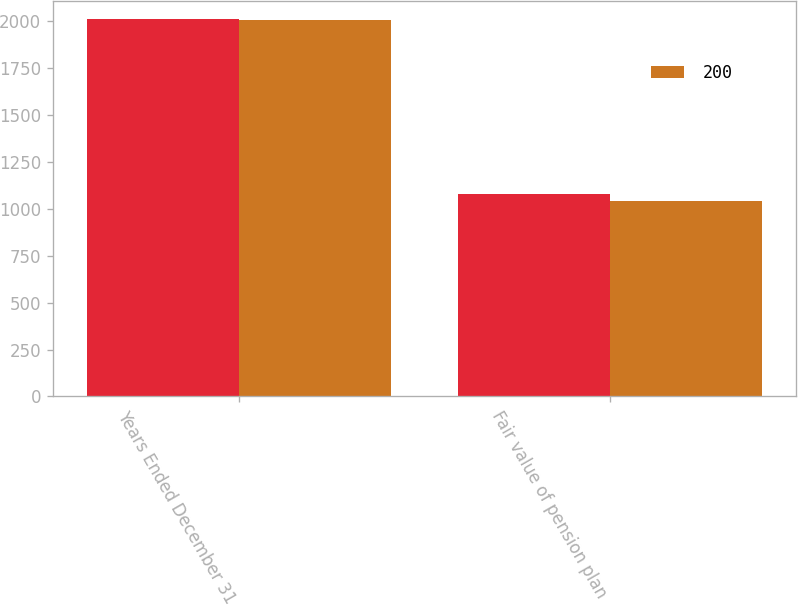<chart> <loc_0><loc_0><loc_500><loc_500><stacked_bar_chart><ecel><fcel>Years Ended December 31<fcel>Fair value of pension plan<nl><fcel>nan<fcel>2007<fcel>1078<nl><fcel>200<fcel>2006<fcel>1040<nl></chart> 